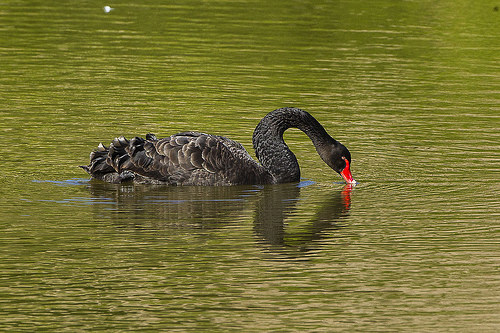<image>
Is the bird on the water? Yes. Looking at the image, I can see the bird is positioned on top of the water, with the water providing support. 